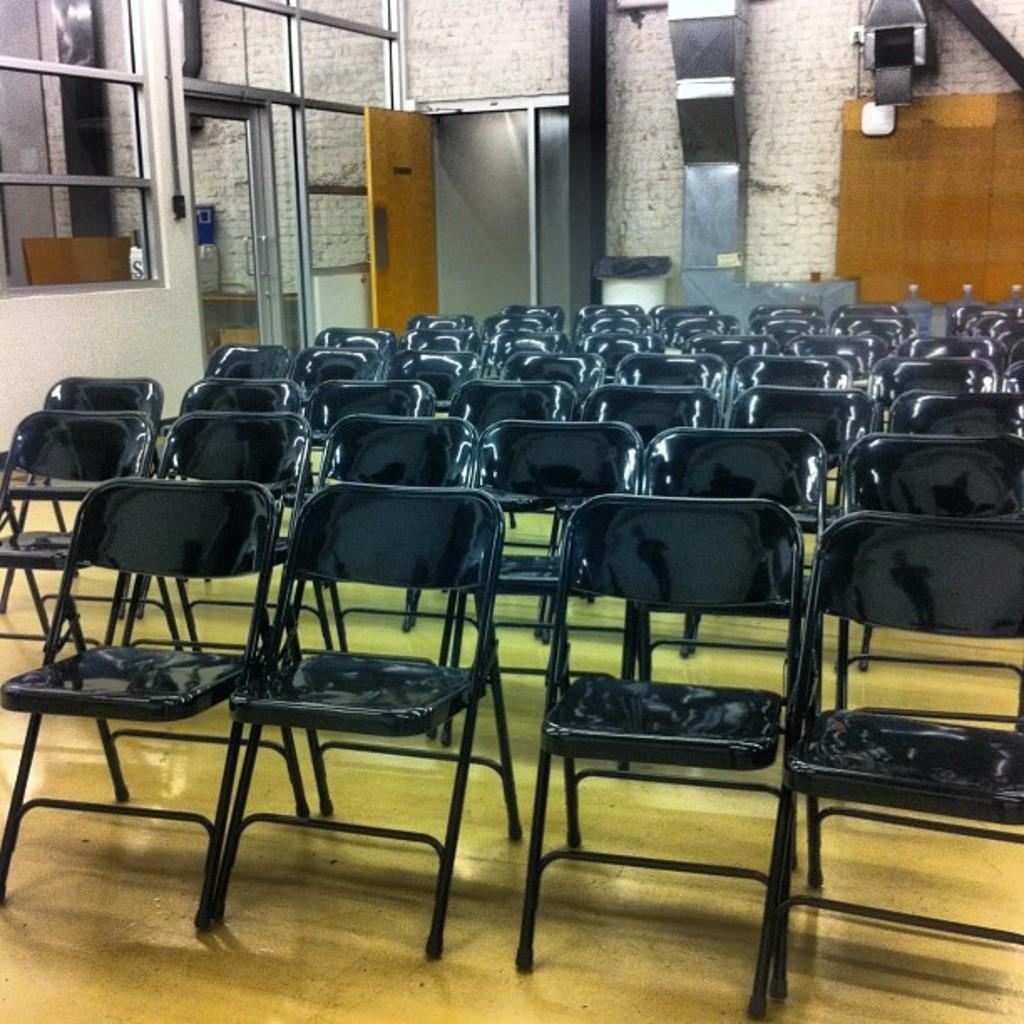What type of furniture is present in the image? There are chairs in the image. What can be seen behind the chairs? There are water tins behind the chairs. What type of entryways are visible in the image? There are doors in the image. What type of transparent barriers are present beside the chairs? There are glass windows beside the chairs. Can you see a zipper on any of the chairs in the image? No, there is no zipper present on any of the chairs in the image. 